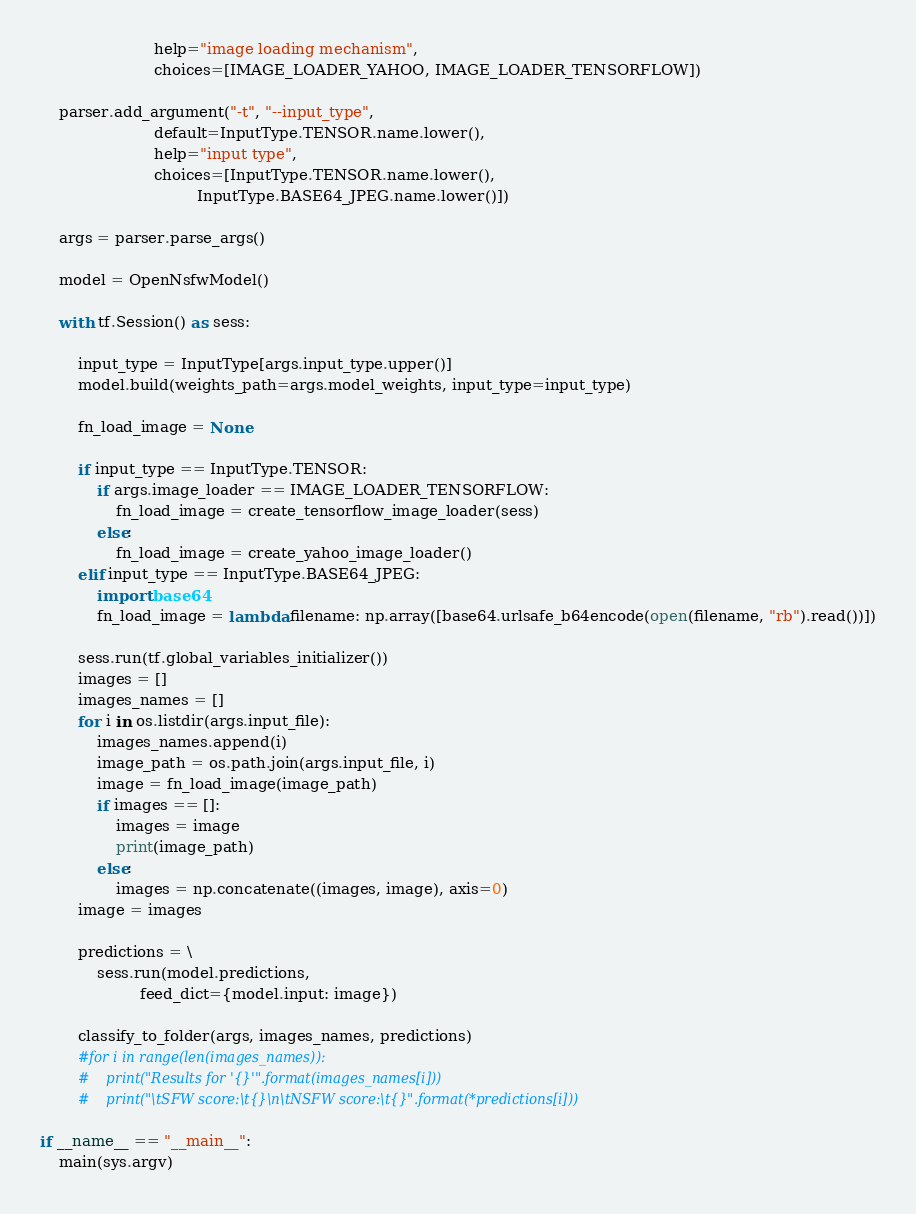Convert code to text. <code><loc_0><loc_0><loc_500><loc_500><_Python_>                        help="image loading mechanism",
                        choices=[IMAGE_LOADER_YAHOO, IMAGE_LOADER_TENSORFLOW])

    parser.add_argument("-t", "--input_type",
                        default=InputType.TENSOR.name.lower(),
                        help="input type",
                        choices=[InputType.TENSOR.name.lower(),
                                 InputType.BASE64_JPEG.name.lower()])

    args = parser.parse_args()

    model = OpenNsfwModel()

    with tf.Session() as sess:

        input_type = InputType[args.input_type.upper()]
        model.build(weights_path=args.model_weights, input_type=input_type)

        fn_load_image = None

        if input_type == InputType.TENSOR:
            if args.image_loader == IMAGE_LOADER_TENSORFLOW:
                fn_load_image = create_tensorflow_image_loader(sess)
            else:
                fn_load_image = create_yahoo_image_loader()
        elif input_type == InputType.BASE64_JPEG:
            import base64
            fn_load_image = lambda filename: np.array([base64.urlsafe_b64encode(open(filename, "rb").read())])

        sess.run(tf.global_variables_initializer())
        images = []
        images_names = []
        for i in os.listdir(args.input_file):
            images_names.append(i)
            image_path = os.path.join(args.input_file, i)
            image = fn_load_image(image_path)
            if images == []:
                images = image
                print(image_path)
            else:
                images = np.concatenate((images, image), axis=0)
        image = images

        predictions = \
            sess.run(model.predictions,
                     feed_dict={model.input: image})

        classify_to_folder(args, images_names, predictions)
        #for i in range(len(images_names)):
        #    print("Results for '{}'".format(images_names[i]))
        #    print("\tSFW score:\t{}\n\tNSFW score:\t{}".format(*predictions[i]))

if __name__ == "__main__":
    main(sys.argv)
</code> 